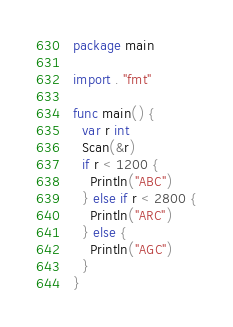Convert code to text. <code><loc_0><loc_0><loc_500><loc_500><_Go_>package main

import . "fmt"

func main() {
  var r int
  Scan(&r)
  if r < 1200 {
    Println("ABC")
  } else if r < 2800 {
    Println("ARC")
  } else {
    Println("AGC")
  }
}</code> 